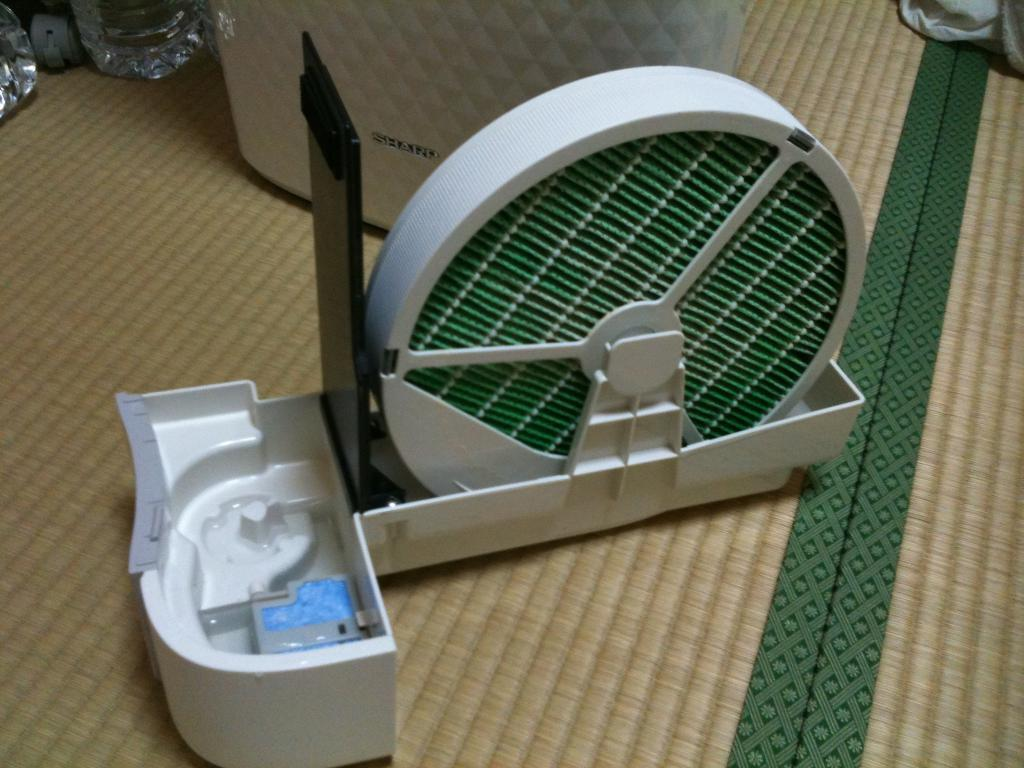What is the main object in the image? There is a machine in the image. Where is the machine placed? The machine is placed on a mat. What is located behind the machine? There is a box behind the machine. What else can be seen in the image besides the machine and box? There are bottles and clothes visible in the image. What type of flight is the mother preparing for in the image? There is no reference to a flight or a mother in the image, so it is not possible to answer that question. 